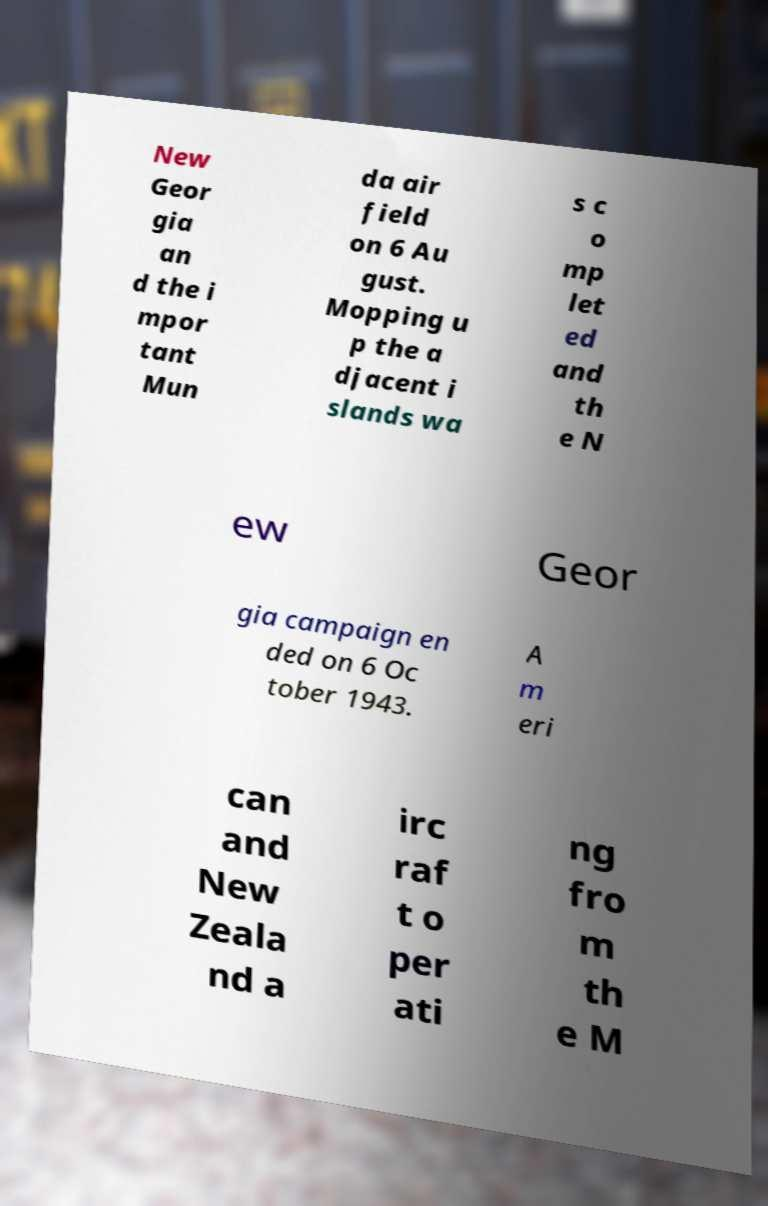Please read and relay the text visible in this image. What does it say? New Geor gia an d the i mpor tant Mun da air field on 6 Au gust. Mopping u p the a djacent i slands wa s c o mp let ed and th e N ew Geor gia campaign en ded on 6 Oc tober 1943. A m eri can and New Zeala nd a irc raf t o per ati ng fro m th e M 